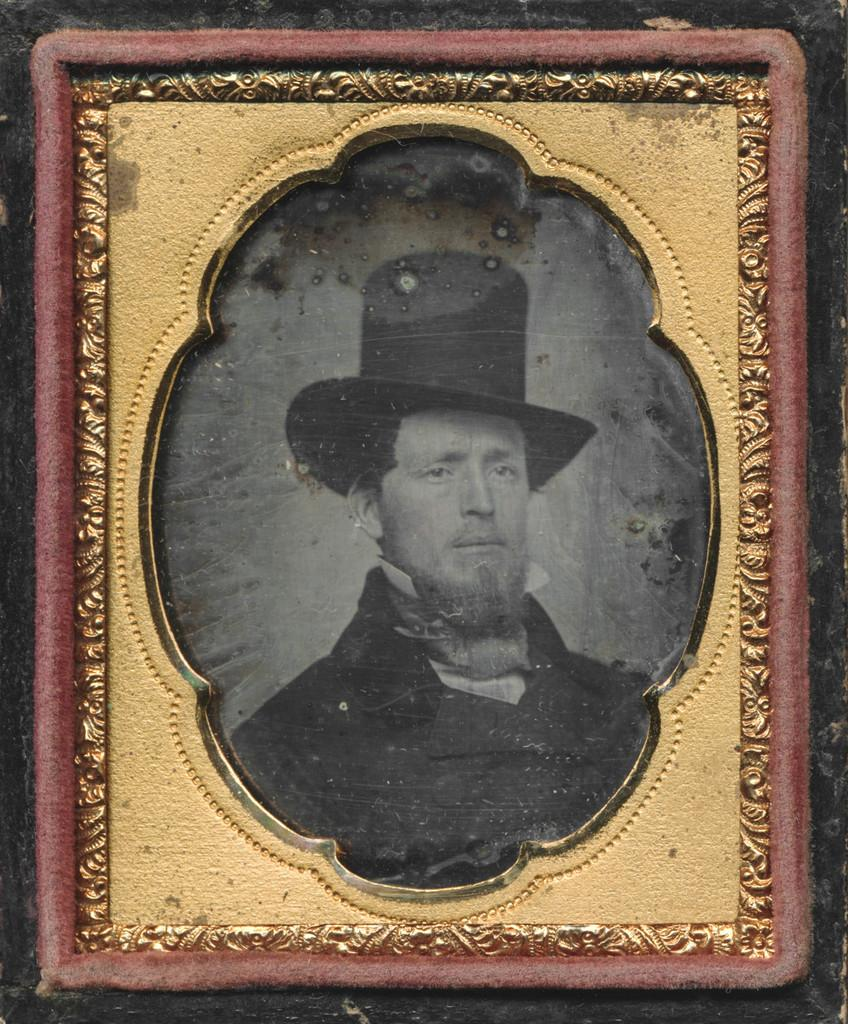What type of artwork is depicted in the image? There is a black and white painting in the image. Who or what is the subject of the painting? The painting is of a man. How is the painting displayed in the image? The painting is in a frame. Where is the frame located in the image? The frame is on a wall. What is the man's income in the painting? The painting is in black and white, and there is no information provided about the man's income. Additionally, the image is a painting and not a photograph, so it is not possible to determine the man's income from the image. 